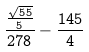Convert formula to latex. <formula><loc_0><loc_0><loc_500><loc_500>\frac { \frac { \sqrt { 5 5 } } { 5 } } { 2 7 8 } - \frac { 1 4 5 } { 4 }</formula> 